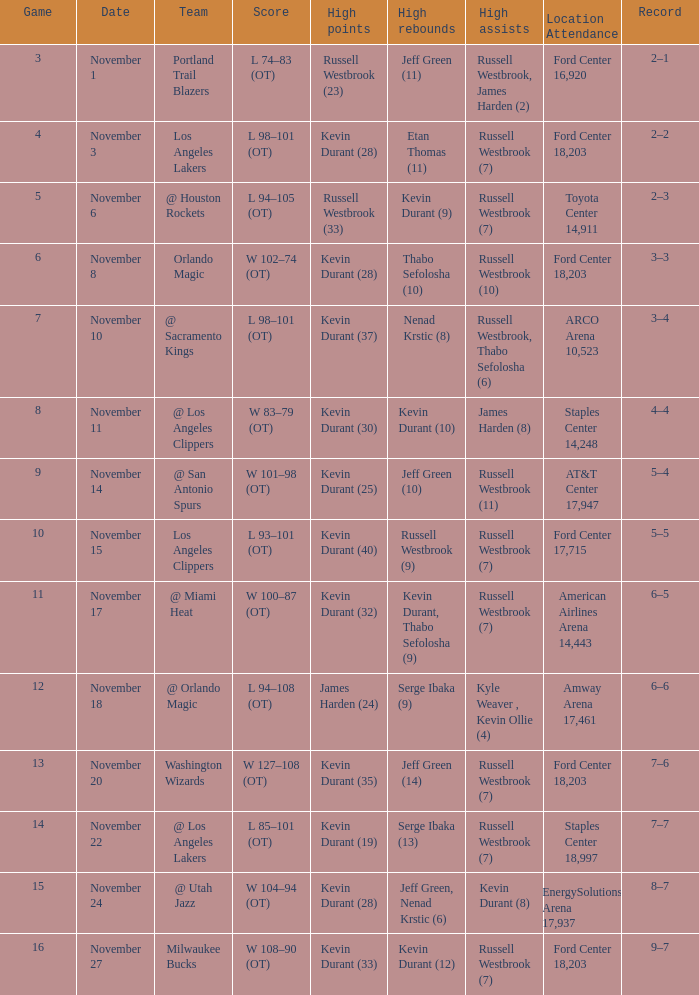When was the game number 3 played? November 1. 